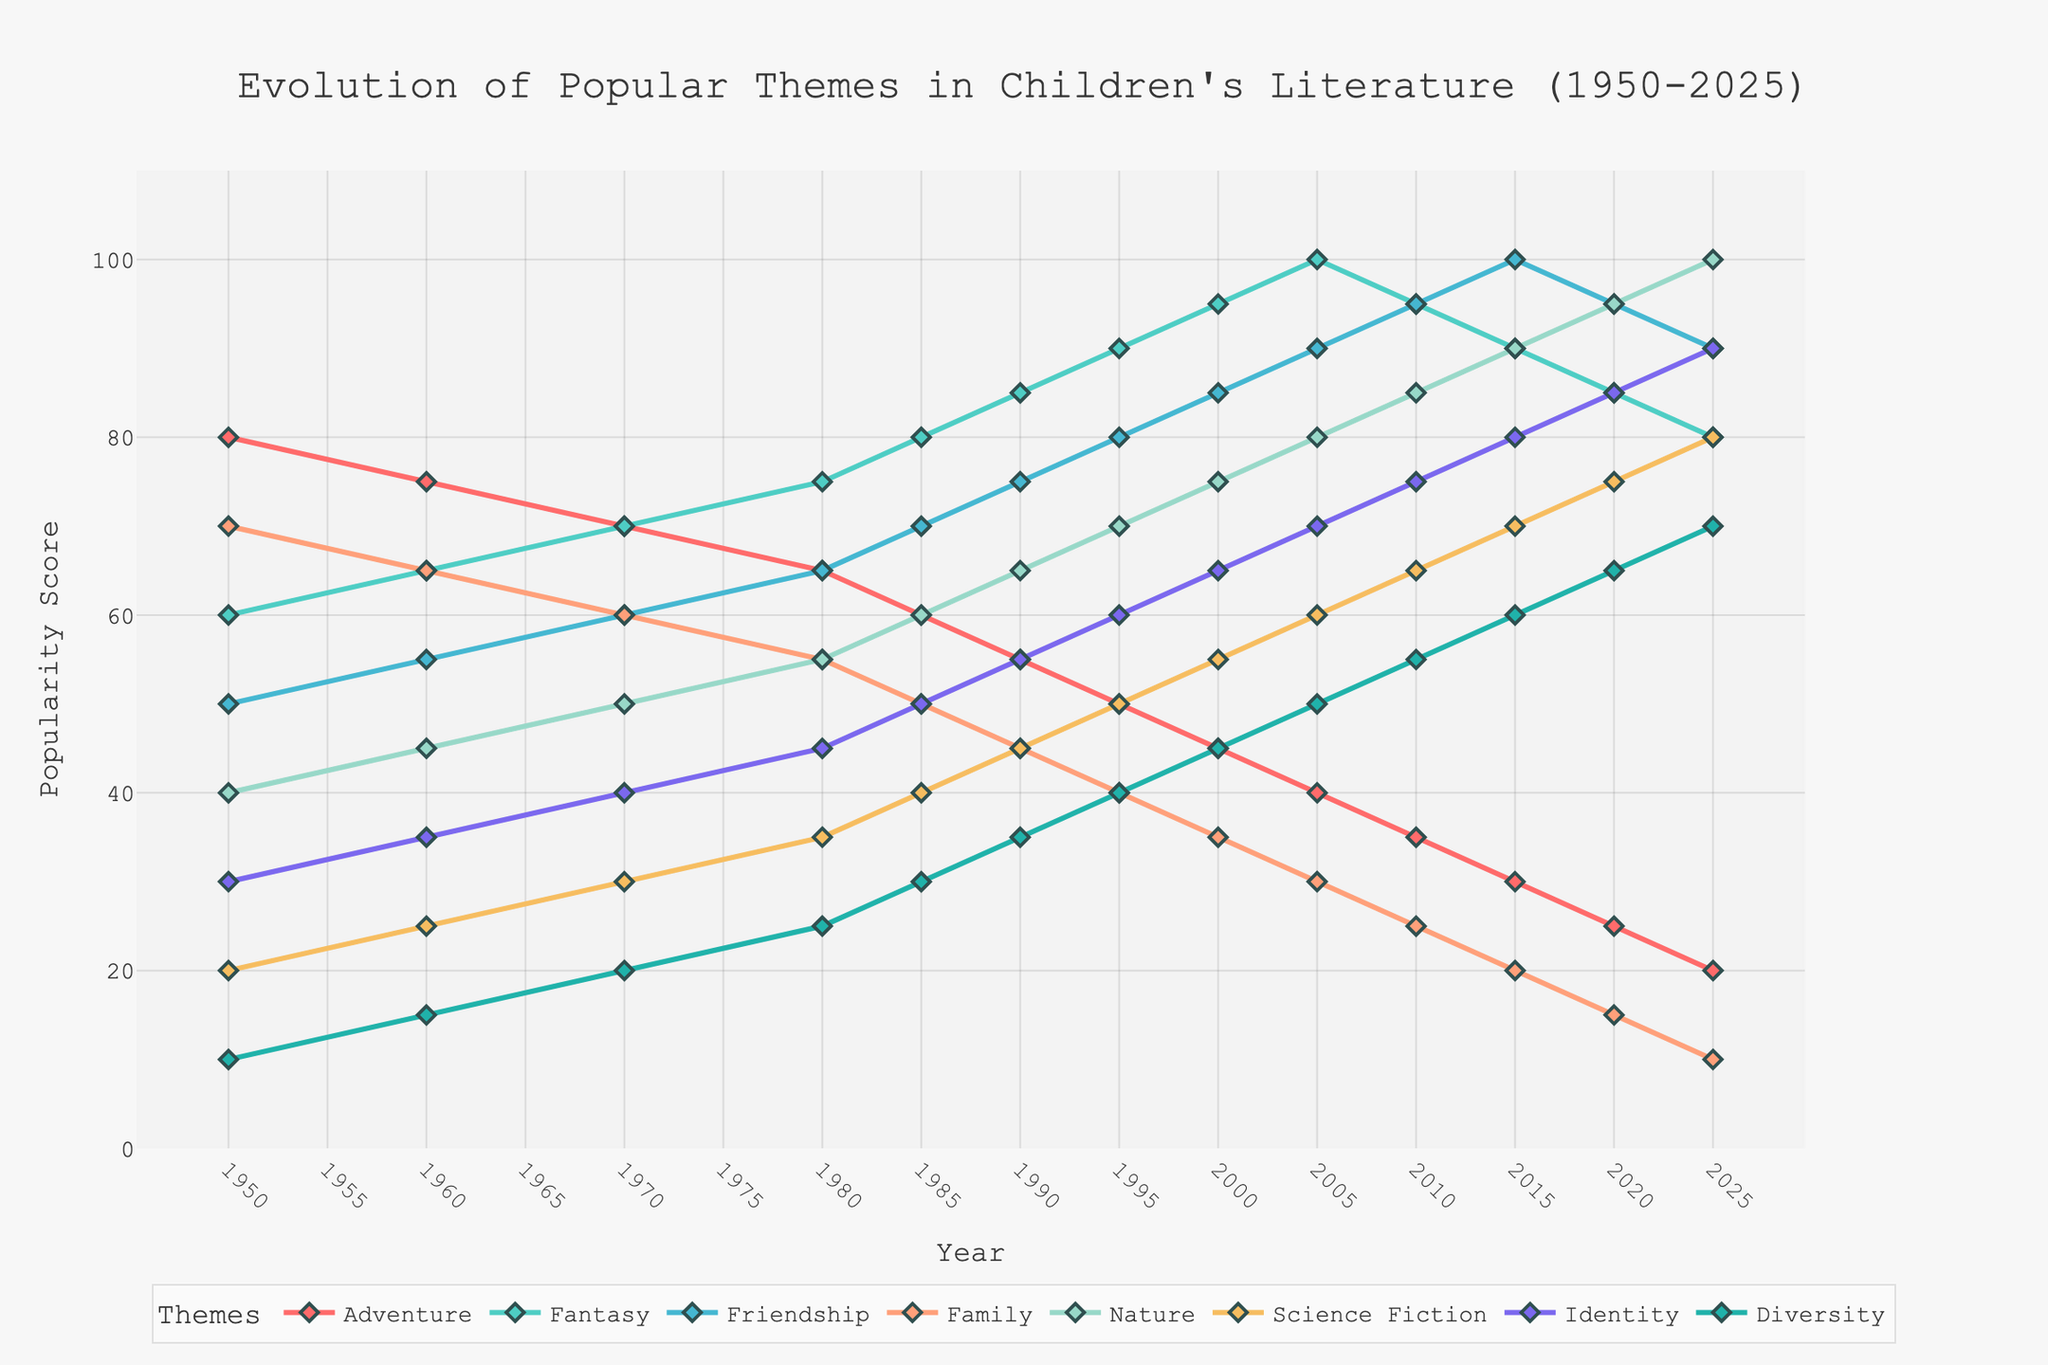Which theme had the highest popularity score in 1950? The theme with the highest popularity score in 1950 can be found by looking at the values for each theme in that year.
Answer: Adventure How has the popularity of the Adventure theme changed from 1950 to 2025? Observe the trend line for Adventure from 1950 to 2025. It starts at 80 and decreases steadily to 20.
Answer: It has decreased What is the average popularity score of the Fantasy theme from 1950 to 2025? Sum the popularity scores of Fantasy for each year and divide by the number of years: (60+65+70+75+80+85+90+95+100+95+90+85+80) / 13
Answer: 80 In which year did the Family theme have the same popularity score as the Friendship theme? Look for the year where the Family and Friendship lines intersect. This happens in 1970.
Answer: 1970 By how much did the popularity score of the Diversity theme increase from 1950 to 2025? Subtract the popularity score of Diversity in 1950 (10) from the score in 2025 (70). 70 - 10 = 60
Answer: 60 Which theme experienced the most significant increase in popularity score from 1950 to 2025? Compare the increase in scores for each theme from 1950 to 2025. Nature increased from 40 to 100, the highest increase of 60 points.
Answer: Nature What is the difference in the popularity score of Science Fiction between 1980 and 1990? Subtract the popularity of Science Fiction in 1980 (35) from the score in 1990 (45). 45 - 35 = 10
Answer: 10 Which theme’s popularity peaked the latest (most recent year) and what was the score? Identify the theme with its highest score in the most recent year. Diversity peaked at 70 in 2025.
Answer: Diversity, 70 Which theme had the lowest score in the year 2000? Find the lowest score among the themes in the year 2000. Family had the lowest score of 35.
Answer: Family, 35 